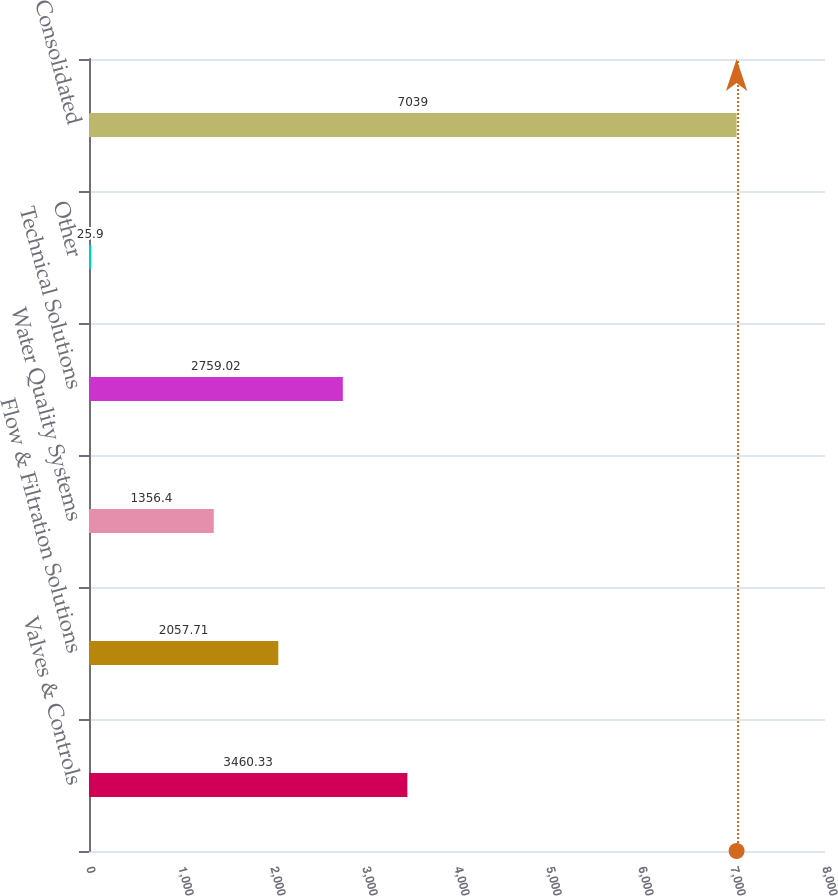Convert chart to OTSL. <chart><loc_0><loc_0><loc_500><loc_500><bar_chart><fcel>Valves & Controls<fcel>Flow & Filtration Solutions<fcel>Water Quality Systems<fcel>Technical Solutions<fcel>Other<fcel>Consolidated<nl><fcel>3460.33<fcel>2057.71<fcel>1356.4<fcel>2759.02<fcel>25.9<fcel>7039<nl></chart> 